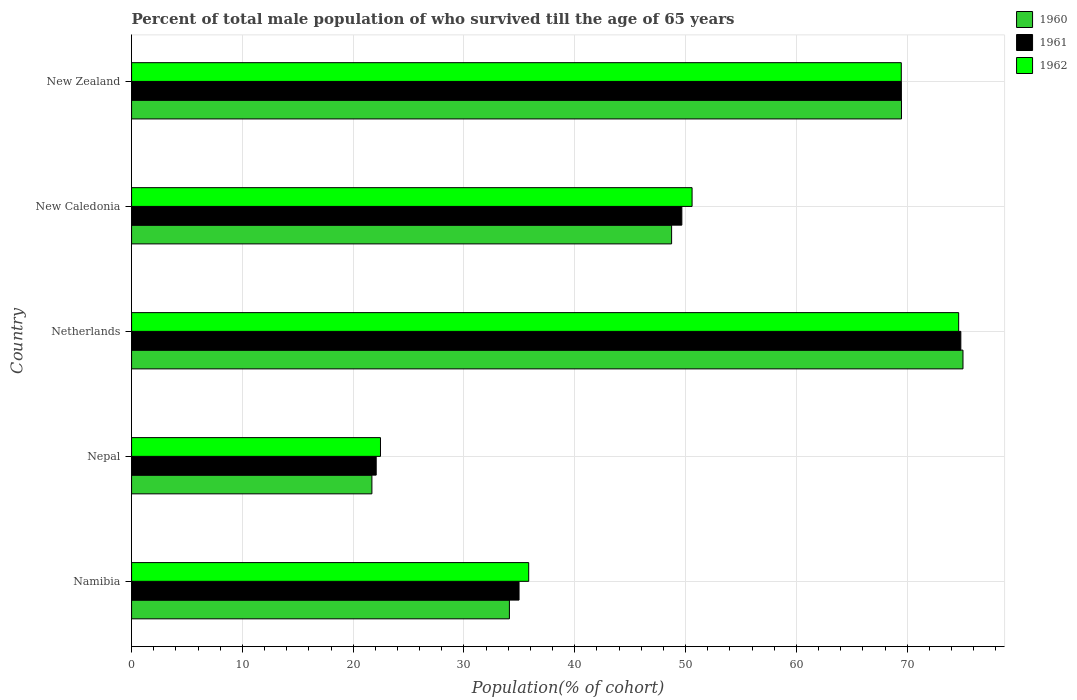How many different coloured bars are there?
Make the answer very short. 3. How many groups of bars are there?
Your answer should be compact. 5. Are the number of bars per tick equal to the number of legend labels?
Make the answer very short. Yes. Are the number of bars on each tick of the Y-axis equal?
Provide a short and direct response. Yes. How many bars are there on the 5th tick from the top?
Your answer should be very brief. 3. How many bars are there on the 3rd tick from the bottom?
Your answer should be compact. 3. What is the label of the 1st group of bars from the top?
Your answer should be compact. New Zealand. In how many cases, is the number of bars for a given country not equal to the number of legend labels?
Offer a very short reply. 0. What is the percentage of total male population who survived till the age of 65 years in 1961 in New Zealand?
Offer a very short reply. 69.48. Across all countries, what is the maximum percentage of total male population who survived till the age of 65 years in 1962?
Keep it short and to the point. 74.65. Across all countries, what is the minimum percentage of total male population who survived till the age of 65 years in 1962?
Your answer should be compact. 22.46. In which country was the percentage of total male population who survived till the age of 65 years in 1962 maximum?
Give a very brief answer. Netherlands. In which country was the percentage of total male population who survived till the age of 65 years in 1960 minimum?
Your response must be concise. Nepal. What is the total percentage of total male population who survived till the age of 65 years in 1960 in the graph?
Your answer should be compact. 249.06. What is the difference between the percentage of total male population who survived till the age of 65 years in 1962 in Namibia and that in Nepal?
Ensure brevity in your answer.  13.38. What is the difference between the percentage of total male population who survived till the age of 65 years in 1962 in New Zealand and the percentage of total male population who survived till the age of 65 years in 1960 in Netherlands?
Provide a short and direct response. -5.57. What is the average percentage of total male population who survived till the age of 65 years in 1962 per country?
Your answer should be compact. 50.6. What is the difference between the percentage of total male population who survived till the age of 65 years in 1962 and percentage of total male population who survived till the age of 65 years in 1961 in Nepal?
Your answer should be very brief. 0.39. In how many countries, is the percentage of total male population who survived till the age of 65 years in 1961 greater than 2 %?
Ensure brevity in your answer.  5. What is the ratio of the percentage of total male population who survived till the age of 65 years in 1961 in Netherlands to that in New Zealand?
Provide a succinct answer. 1.08. Is the difference between the percentage of total male population who survived till the age of 65 years in 1962 in Namibia and New Zealand greater than the difference between the percentage of total male population who survived till the age of 65 years in 1961 in Namibia and New Zealand?
Keep it short and to the point. Yes. What is the difference between the highest and the second highest percentage of total male population who survived till the age of 65 years in 1960?
Keep it short and to the point. 5.55. What is the difference between the highest and the lowest percentage of total male population who survived till the age of 65 years in 1961?
Provide a succinct answer. 52.77. Is the sum of the percentage of total male population who survived till the age of 65 years in 1960 in New Caledonia and New Zealand greater than the maximum percentage of total male population who survived till the age of 65 years in 1961 across all countries?
Provide a short and direct response. Yes. What does the 3rd bar from the top in Netherlands represents?
Provide a short and direct response. 1960. How many bars are there?
Offer a terse response. 15. How many countries are there in the graph?
Give a very brief answer. 5. What is the difference between two consecutive major ticks on the X-axis?
Offer a terse response. 10. Are the values on the major ticks of X-axis written in scientific E-notation?
Keep it short and to the point. No. Does the graph contain grids?
Provide a succinct answer. Yes. Where does the legend appear in the graph?
Give a very brief answer. Top right. How many legend labels are there?
Your response must be concise. 3. What is the title of the graph?
Your answer should be very brief. Percent of total male population of who survived till the age of 65 years. Does "1980" appear as one of the legend labels in the graph?
Offer a very short reply. No. What is the label or title of the X-axis?
Give a very brief answer. Population(% of cohort). What is the label or title of the Y-axis?
Make the answer very short. Country. What is the Population(% of cohort) in 1960 in Namibia?
Keep it short and to the point. 34.1. What is the Population(% of cohort) in 1961 in Namibia?
Give a very brief answer. 34.97. What is the Population(% of cohort) of 1962 in Namibia?
Give a very brief answer. 35.84. What is the Population(% of cohort) in 1960 in Nepal?
Your response must be concise. 21.69. What is the Population(% of cohort) in 1961 in Nepal?
Your answer should be compact. 22.08. What is the Population(% of cohort) of 1962 in Nepal?
Give a very brief answer. 22.46. What is the Population(% of cohort) in 1960 in Netherlands?
Make the answer very short. 75.04. What is the Population(% of cohort) of 1961 in Netherlands?
Offer a very short reply. 74.84. What is the Population(% of cohort) in 1962 in Netherlands?
Your response must be concise. 74.65. What is the Population(% of cohort) in 1960 in New Caledonia?
Your response must be concise. 48.74. What is the Population(% of cohort) in 1961 in New Caledonia?
Ensure brevity in your answer.  49.66. What is the Population(% of cohort) in 1962 in New Caledonia?
Your answer should be very brief. 50.59. What is the Population(% of cohort) in 1960 in New Zealand?
Offer a terse response. 69.49. What is the Population(% of cohort) of 1961 in New Zealand?
Keep it short and to the point. 69.48. What is the Population(% of cohort) of 1962 in New Zealand?
Make the answer very short. 69.47. Across all countries, what is the maximum Population(% of cohort) of 1960?
Ensure brevity in your answer.  75.04. Across all countries, what is the maximum Population(% of cohort) in 1961?
Provide a succinct answer. 74.84. Across all countries, what is the maximum Population(% of cohort) in 1962?
Keep it short and to the point. 74.65. Across all countries, what is the minimum Population(% of cohort) of 1960?
Provide a short and direct response. 21.69. Across all countries, what is the minimum Population(% of cohort) in 1961?
Your response must be concise. 22.08. Across all countries, what is the minimum Population(% of cohort) of 1962?
Your response must be concise. 22.46. What is the total Population(% of cohort) in 1960 in the graph?
Offer a very short reply. 249.06. What is the total Population(% of cohort) of 1961 in the graph?
Provide a short and direct response. 251.04. What is the total Population(% of cohort) of 1962 in the graph?
Provide a succinct answer. 253.02. What is the difference between the Population(% of cohort) of 1960 in Namibia and that in Nepal?
Your response must be concise. 12.41. What is the difference between the Population(% of cohort) in 1961 in Namibia and that in Nepal?
Offer a very short reply. 12.89. What is the difference between the Population(% of cohort) in 1962 in Namibia and that in Nepal?
Your response must be concise. 13.38. What is the difference between the Population(% of cohort) in 1960 in Namibia and that in Netherlands?
Ensure brevity in your answer.  -40.94. What is the difference between the Population(% of cohort) in 1961 in Namibia and that in Netherlands?
Provide a short and direct response. -39.87. What is the difference between the Population(% of cohort) of 1962 in Namibia and that in Netherlands?
Offer a very short reply. -38.81. What is the difference between the Population(% of cohort) of 1960 in Namibia and that in New Caledonia?
Give a very brief answer. -14.64. What is the difference between the Population(% of cohort) in 1961 in Namibia and that in New Caledonia?
Give a very brief answer. -14.69. What is the difference between the Population(% of cohort) of 1962 in Namibia and that in New Caledonia?
Ensure brevity in your answer.  -14.75. What is the difference between the Population(% of cohort) in 1960 in Namibia and that in New Zealand?
Give a very brief answer. -35.39. What is the difference between the Population(% of cohort) in 1961 in Namibia and that in New Zealand?
Your answer should be compact. -34.51. What is the difference between the Population(% of cohort) in 1962 in Namibia and that in New Zealand?
Your answer should be compact. -33.63. What is the difference between the Population(% of cohort) in 1960 in Nepal and that in Netherlands?
Give a very brief answer. -53.35. What is the difference between the Population(% of cohort) in 1961 in Nepal and that in Netherlands?
Your answer should be very brief. -52.77. What is the difference between the Population(% of cohort) in 1962 in Nepal and that in Netherlands?
Your answer should be very brief. -52.19. What is the difference between the Population(% of cohort) in 1960 in Nepal and that in New Caledonia?
Your response must be concise. -27.05. What is the difference between the Population(% of cohort) in 1961 in Nepal and that in New Caledonia?
Offer a very short reply. -27.59. What is the difference between the Population(% of cohort) in 1962 in Nepal and that in New Caledonia?
Keep it short and to the point. -28.12. What is the difference between the Population(% of cohort) in 1960 in Nepal and that in New Zealand?
Your answer should be very brief. -47.8. What is the difference between the Population(% of cohort) in 1961 in Nepal and that in New Zealand?
Give a very brief answer. -47.4. What is the difference between the Population(% of cohort) in 1962 in Nepal and that in New Zealand?
Ensure brevity in your answer.  -47.01. What is the difference between the Population(% of cohort) of 1960 in Netherlands and that in New Caledonia?
Your answer should be very brief. 26.3. What is the difference between the Population(% of cohort) of 1961 in Netherlands and that in New Caledonia?
Your response must be concise. 25.18. What is the difference between the Population(% of cohort) of 1962 in Netherlands and that in New Caledonia?
Keep it short and to the point. 24.06. What is the difference between the Population(% of cohort) in 1960 in Netherlands and that in New Zealand?
Ensure brevity in your answer.  5.55. What is the difference between the Population(% of cohort) in 1961 in Netherlands and that in New Zealand?
Your answer should be very brief. 5.36. What is the difference between the Population(% of cohort) in 1962 in Netherlands and that in New Zealand?
Make the answer very short. 5.18. What is the difference between the Population(% of cohort) in 1960 in New Caledonia and that in New Zealand?
Ensure brevity in your answer.  -20.75. What is the difference between the Population(% of cohort) in 1961 in New Caledonia and that in New Zealand?
Provide a short and direct response. -19.82. What is the difference between the Population(% of cohort) in 1962 in New Caledonia and that in New Zealand?
Offer a very short reply. -18.88. What is the difference between the Population(% of cohort) of 1960 in Namibia and the Population(% of cohort) of 1961 in Nepal?
Keep it short and to the point. 12.02. What is the difference between the Population(% of cohort) of 1960 in Namibia and the Population(% of cohort) of 1962 in Nepal?
Provide a short and direct response. 11.64. What is the difference between the Population(% of cohort) in 1961 in Namibia and the Population(% of cohort) in 1962 in Nepal?
Your answer should be very brief. 12.51. What is the difference between the Population(% of cohort) in 1960 in Namibia and the Population(% of cohort) in 1961 in Netherlands?
Keep it short and to the point. -40.74. What is the difference between the Population(% of cohort) of 1960 in Namibia and the Population(% of cohort) of 1962 in Netherlands?
Your answer should be compact. -40.55. What is the difference between the Population(% of cohort) in 1961 in Namibia and the Population(% of cohort) in 1962 in Netherlands?
Offer a very short reply. -39.68. What is the difference between the Population(% of cohort) of 1960 in Namibia and the Population(% of cohort) of 1961 in New Caledonia?
Your response must be concise. -15.56. What is the difference between the Population(% of cohort) in 1960 in Namibia and the Population(% of cohort) in 1962 in New Caledonia?
Offer a terse response. -16.49. What is the difference between the Population(% of cohort) of 1961 in Namibia and the Population(% of cohort) of 1962 in New Caledonia?
Give a very brief answer. -15.62. What is the difference between the Population(% of cohort) of 1960 in Namibia and the Population(% of cohort) of 1961 in New Zealand?
Make the answer very short. -35.38. What is the difference between the Population(% of cohort) of 1960 in Namibia and the Population(% of cohort) of 1962 in New Zealand?
Your response must be concise. -35.37. What is the difference between the Population(% of cohort) in 1961 in Namibia and the Population(% of cohort) in 1962 in New Zealand?
Keep it short and to the point. -34.5. What is the difference between the Population(% of cohort) in 1960 in Nepal and the Population(% of cohort) in 1961 in Netherlands?
Offer a terse response. -53.15. What is the difference between the Population(% of cohort) of 1960 in Nepal and the Population(% of cohort) of 1962 in Netherlands?
Your response must be concise. -52.96. What is the difference between the Population(% of cohort) of 1961 in Nepal and the Population(% of cohort) of 1962 in Netherlands?
Offer a very short reply. -52.57. What is the difference between the Population(% of cohort) in 1960 in Nepal and the Population(% of cohort) in 1961 in New Caledonia?
Make the answer very short. -27.97. What is the difference between the Population(% of cohort) in 1960 in Nepal and the Population(% of cohort) in 1962 in New Caledonia?
Offer a very short reply. -28.9. What is the difference between the Population(% of cohort) in 1961 in Nepal and the Population(% of cohort) in 1962 in New Caledonia?
Make the answer very short. -28.51. What is the difference between the Population(% of cohort) in 1960 in Nepal and the Population(% of cohort) in 1961 in New Zealand?
Ensure brevity in your answer.  -47.79. What is the difference between the Population(% of cohort) in 1960 in Nepal and the Population(% of cohort) in 1962 in New Zealand?
Provide a succinct answer. -47.78. What is the difference between the Population(% of cohort) in 1961 in Nepal and the Population(% of cohort) in 1962 in New Zealand?
Keep it short and to the point. -47.39. What is the difference between the Population(% of cohort) in 1960 in Netherlands and the Population(% of cohort) in 1961 in New Caledonia?
Make the answer very short. 25.37. What is the difference between the Population(% of cohort) in 1960 in Netherlands and the Population(% of cohort) in 1962 in New Caledonia?
Provide a short and direct response. 24.45. What is the difference between the Population(% of cohort) in 1961 in Netherlands and the Population(% of cohort) in 1962 in New Caledonia?
Your answer should be compact. 24.26. What is the difference between the Population(% of cohort) of 1960 in Netherlands and the Population(% of cohort) of 1961 in New Zealand?
Your answer should be very brief. 5.56. What is the difference between the Population(% of cohort) in 1960 in Netherlands and the Population(% of cohort) in 1962 in New Zealand?
Your answer should be very brief. 5.57. What is the difference between the Population(% of cohort) of 1961 in Netherlands and the Population(% of cohort) of 1962 in New Zealand?
Make the answer very short. 5.37. What is the difference between the Population(% of cohort) in 1960 in New Caledonia and the Population(% of cohort) in 1961 in New Zealand?
Offer a very short reply. -20.74. What is the difference between the Population(% of cohort) in 1960 in New Caledonia and the Population(% of cohort) in 1962 in New Zealand?
Offer a very short reply. -20.73. What is the difference between the Population(% of cohort) of 1961 in New Caledonia and the Population(% of cohort) of 1962 in New Zealand?
Ensure brevity in your answer.  -19.81. What is the average Population(% of cohort) in 1960 per country?
Provide a short and direct response. 49.81. What is the average Population(% of cohort) of 1961 per country?
Provide a succinct answer. 50.21. What is the average Population(% of cohort) of 1962 per country?
Your response must be concise. 50.6. What is the difference between the Population(% of cohort) of 1960 and Population(% of cohort) of 1961 in Namibia?
Ensure brevity in your answer.  -0.87. What is the difference between the Population(% of cohort) of 1960 and Population(% of cohort) of 1962 in Namibia?
Make the answer very short. -1.74. What is the difference between the Population(% of cohort) of 1961 and Population(% of cohort) of 1962 in Namibia?
Offer a very short reply. -0.87. What is the difference between the Population(% of cohort) of 1960 and Population(% of cohort) of 1961 in Nepal?
Keep it short and to the point. -0.39. What is the difference between the Population(% of cohort) in 1960 and Population(% of cohort) in 1962 in Nepal?
Provide a short and direct response. -0.77. What is the difference between the Population(% of cohort) of 1961 and Population(% of cohort) of 1962 in Nepal?
Offer a terse response. -0.39. What is the difference between the Population(% of cohort) in 1960 and Population(% of cohort) in 1961 in Netherlands?
Your answer should be very brief. 0.19. What is the difference between the Population(% of cohort) of 1960 and Population(% of cohort) of 1962 in Netherlands?
Provide a succinct answer. 0.39. What is the difference between the Population(% of cohort) of 1961 and Population(% of cohort) of 1962 in Netherlands?
Your answer should be compact. 0.19. What is the difference between the Population(% of cohort) of 1960 and Population(% of cohort) of 1961 in New Caledonia?
Your answer should be compact. -0.92. What is the difference between the Population(% of cohort) in 1960 and Population(% of cohort) in 1962 in New Caledonia?
Offer a very short reply. -1.85. What is the difference between the Population(% of cohort) in 1961 and Population(% of cohort) in 1962 in New Caledonia?
Make the answer very short. -0.92. What is the difference between the Population(% of cohort) of 1960 and Population(% of cohort) of 1961 in New Zealand?
Ensure brevity in your answer.  0.01. What is the difference between the Population(% of cohort) of 1960 and Population(% of cohort) of 1962 in New Zealand?
Your response must be concise. 0.02. What is the difference between the Population(% of cohort) of 1961 and Population(% of cohort) of 1962 in New Zealand?
Your answer should be compact. 0.01. What is the ratio of the Population(% of cohort) of 1960 in Namibia to that in Nepal?
Make the answer very short. 1.57. What is the ratio of the Population(% of cohort) in 1961 in Namibia to that in Nepal?
Offer a very short reply. 1.58. What is the ratio of the Population(% of cohort) of 1962 in Namibia to that in Nepal?
Provide a succinct answer. 1.6. What is the ratio of the Population(% of cohort) in 1960 in Namibia to that in Netherlands?
Offer a terse response. 0.45. What is the ratio of the Population(% of cohort) in 1961 in Namibia to that in Netherlands?
Provide a succinct answer. 0.47. What is the ratio of the Population(% of cohort) in 1962 in Namibia to that in Netherlands?
Provide a succinct answer. 0.48. What is the ratio of the Population(% of cohort) of 1960 in Namibia to that in New Caledonia?
Offer a very short reply. 0.7. What is the ratio of the Population(% of cohort) in 1961 in Namibia to that in New Caledonia?
Provide a short and direct response. 0.7. What is the ratio of the Population(% of cohort) in 1962 in Namibia to that in New Caledonia?
Make the answer very short. 0.71. What is the ratio of the Population(% of cohort) in 1960 in Namibia to that in New Zealand?
Make the answer very short. 0.49. What is the ratio of the Population(% of cohort) in 1961 in Namibia to that in New Zealand?
Keep it short and to the point. 0.5. What is the ratio of the Population(% of cohort) in 1962 in Namibia to that in New Zealand?
Your answer should be compact. 0.52. What is the ratio of the Population(% of cohort) of 1960 in Nepal to that in Netherlands?
Your answer should be compact. 0.29. What is the ratio of the Population(% of cohort) of 1961 in Nepal to that in Netherlands?
Offer a very short reply. 0.29. What is the ratio of the Population(% of cohort) of 1962 in Nepal to that in Netherlands?
Make the answer very short. 0.3. What is the ratio of the Population(% of cohort) in 1960 in Nepal to that in New Caledonia?
Make the answer very short. 0.45. What is the ratio of the Population(% of cohort) of 1961 in Nepal to that in New Caledonia?
Ensure brevity in your answer.  0.44. What is the ratio of the Population(% of cohort) of 1962 in Nepal to that in New Caledonia?
Make the answer very short. 0.44. What is the ratio of the Population(% of cohort) of 1960 in Nepal to that in New Zealand?
Provide a short and direct response. 0.31. What is the ratio of the Population(% of cohort) in 1961 in Nepal to that in New Zealand?
Your response must be concise. 0.32. What is the ratio of the Population(% of cohort) of 1962 in Nepal to that in New Zealand?
Provide a succinct answer. 0.32. What is the ratio of the Population(% of cohort) in 1960 in Netherlands to that in New Caledonia?
Offer a terse response. 1.54. What is the ratio of the Population(% of cohort) in 1961 in Netherlands to that in New Caledonia?
Ensure brevity in your answer.  1.51. What is the ratio of the Population(% of cohort) in 1962 in Netherlands to that in New Caledonia?
Give a very brief answer. 1.48. What is the ratio of the Population(% of cohort) of 1960 in Netherlands to that in New Zealand?
Offer a very short reply. 1.08. What is the ratio of the Population(% of cohort) of 1961 in Netherlands to that in New Zealand?
Provide a succinct answer. 1.08. What is the ratio of the Population(% of cohort) in 1962 in Netherlands to that in New Zealand?
Give a very brief answer. 1.07. What is the ratio of the Population(% of cohort) in 1960 in New Caledonia to that in New Zealand?
Give a very brief answer. 0.7. What is the ratio of the Population(% of cohort) of 1961 in New Caledonia to that in New Zealand?
Make the answer very short. 0.71. What is the ratio of the Population(% of cohort) in 1962 in New Caledonia to that in New Zealand?
Give a very brief answer. 0.73. What is the difference between the highest and the second highest Population(% of cohort) of 1960?
Give a very brief answer. 5.55. What is the difference between the highest and the second highest Population(% of cohort) of 1961?
Keep it short and to the point. 5.36. What is the difference between the highest and the second highest Population(% of cohort) of 1962?
Your answer should be compact. 5.18. What is the difference between the highest and the lowest Population(% of cohort) of 1960?
Your answer should be very brief. 53.35. What is the difference between the highest and the lowest Population(% of cohort) of 1961?
Your answer should be very brief. 52.77. What is the difference between the highest and the lowest Population(% of cohort) in 1962?
Offer a terse response. 52.19. 